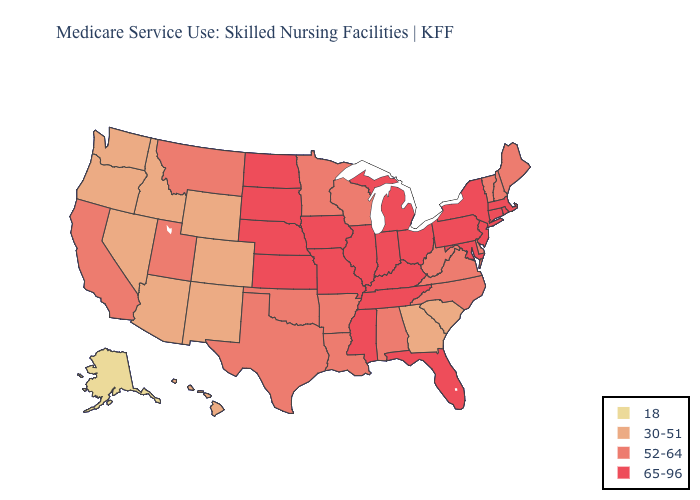Does New Hampshire have the highest value in the USA?
Concise answer only. No. What is the value of Arizona?
Short answer required. 30-51. Does the map have missing data?
Write a very short answer. No. What is the lowest value in states that border Kansas?
Be succinct. 30-51. Does Delaware have the same value as Maine?
Short answer required. Yes. What is the value of Texas?
Give a very brief answer. 52-64. Name the states that have a value in the range 30-51?
Concise answer only. Arizona, Colorado, Georgia, Hawaii, Idaho, Nevada, New Mexico, Oregon, South Carolina, Washington, Wyoming. Among the states that border Massachusetts , does Rhode Island have the lowest value?
Short answer required. No. Does South Carolina have a higher value than Florida?
Give a very brief answer. No. Name the states that have a value in the range 18?
Short answer required. Alaska. Among the states that border Arkansas , does Missouri have the lowest value?
Short answer required. No. Does Alaska have the lowest value in the USA?
Keep it brief. Yes. Does Pennsylvania have a higher value than Illinois?
Be succinct. No. Name the states that have a value in the range 18?
Write a very short answer. Alaska. Does Arizona have a lower value than Nevada?
Answer briefly. No. 